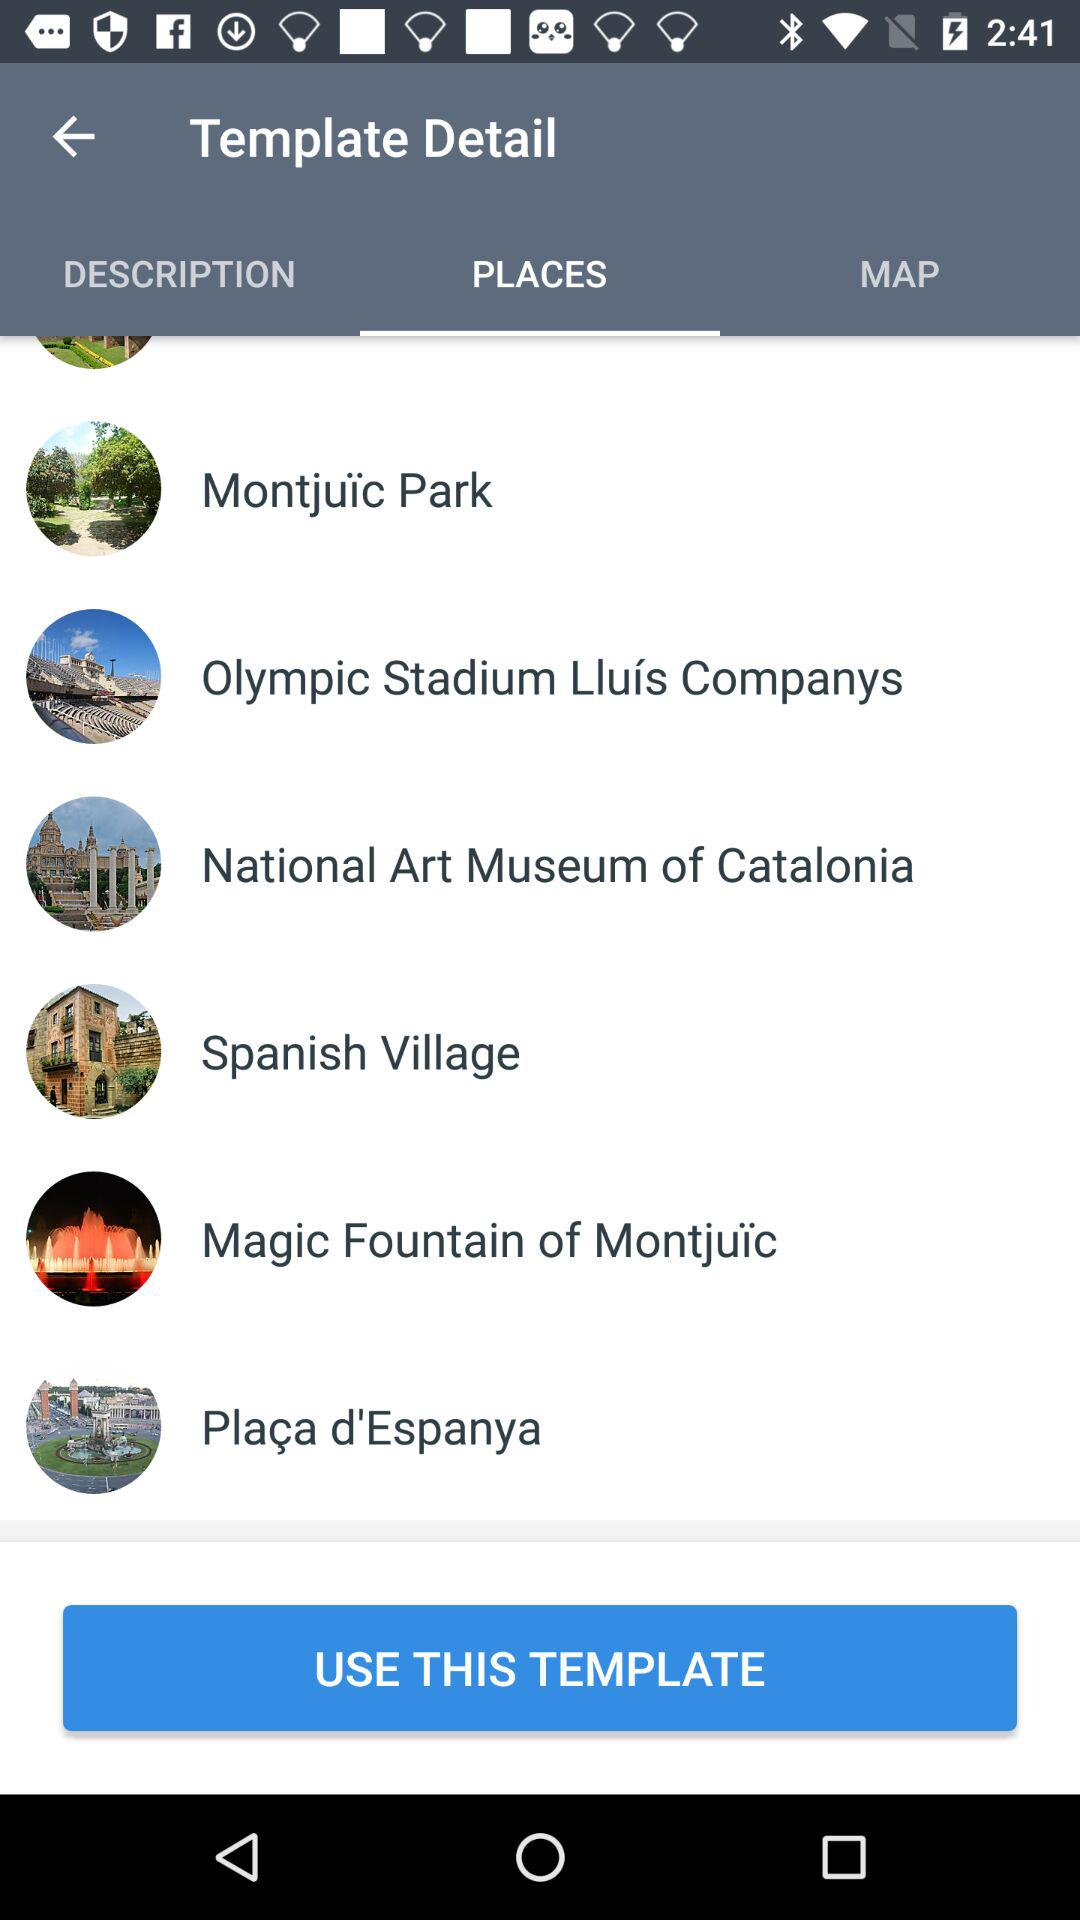Which option is selected? The selected option is "PLACES". 